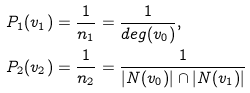Convert formula to latex. <formula><loc_0><loc_0><loc_500><loc_500>P _ { 1 } ( v _ { 1 } ) & = \frac { 1 } { n _ { 1 } } = \frac { 1 } { d e g ( v _ { 0 } ) } , \\ P _ { 2 } ( v _ { 2 } ) & = \frac { 1 } { n _ { 2 } } = \frac { 1 } { | N ( v _ { 0 } ) | \cap | N ( v _ { 1 } ) | }</formula> 